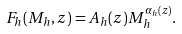<formula> <loc_0><loc_0><loc_500><loc_500>F _ { h } ( M _ { h } , z ) = A _ { h } ( z ) M _ { h } ^ { \alpha _ { h } ( z ) } .</formula> 